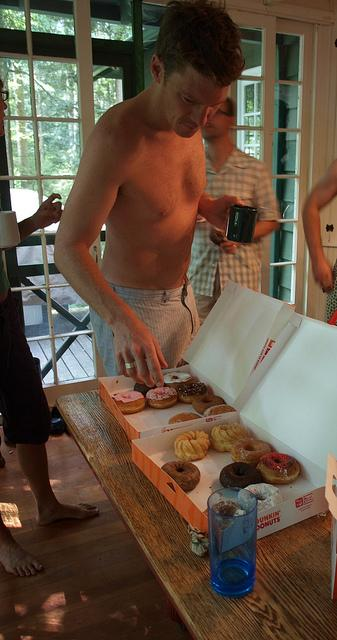What color is the icing on the top of the donuts underneath of the man's hand who is looking to eat? Please explain your reasoning. pink. The color is pink. 